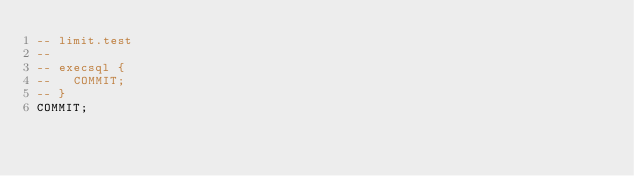<code> <loc_0><loc_0><loc_500><loc_500><_SQL_>-- limit.test
-- 
-- execsql {
--   COMMIT;
-- }
COMMIT;</code> 